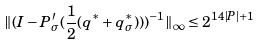<formula> <loc_0><loc_0><loc_500><loc_500>\| ( I - P ^ { \prime } _ { \sigma } ( \frac { 1 } { 2 } ( q ^ { * } + q ^ { * } _ { \sigma } ) ) ) ^ { - 1 } \| _ { \infty } \leq 2 ^ { 1 4 | P | + 1 }</formula> 